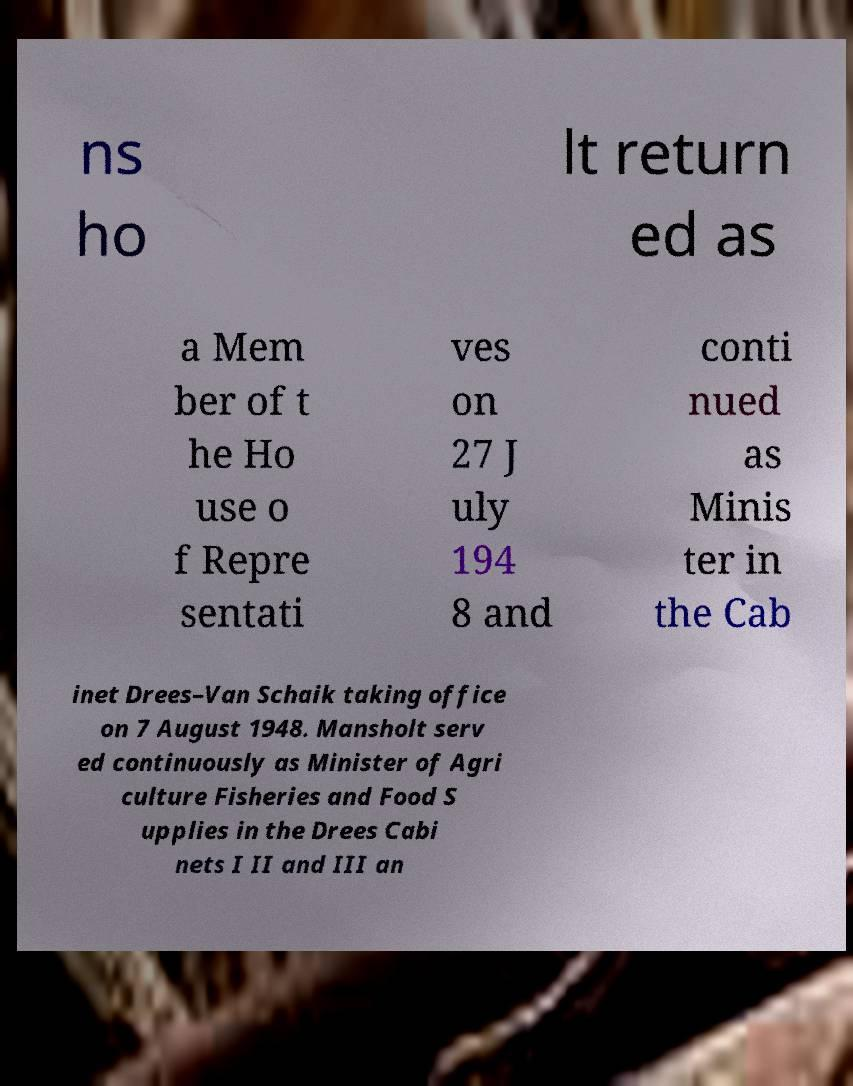Please read and relay the text visible in this image. What does it say? ns ho lt return ed as a Mem ber of t he Ho use o f Repre sentati ves on 27 J uly 194 8 and conti nued as Minis ter in the Cab inet Drees–Van Schaik taking office on 7 August 1948. Mansholt serv ed continuously as Minister of Agri culture Fisheries and Food S upplies in the Drees Cabi nets I II and III an 